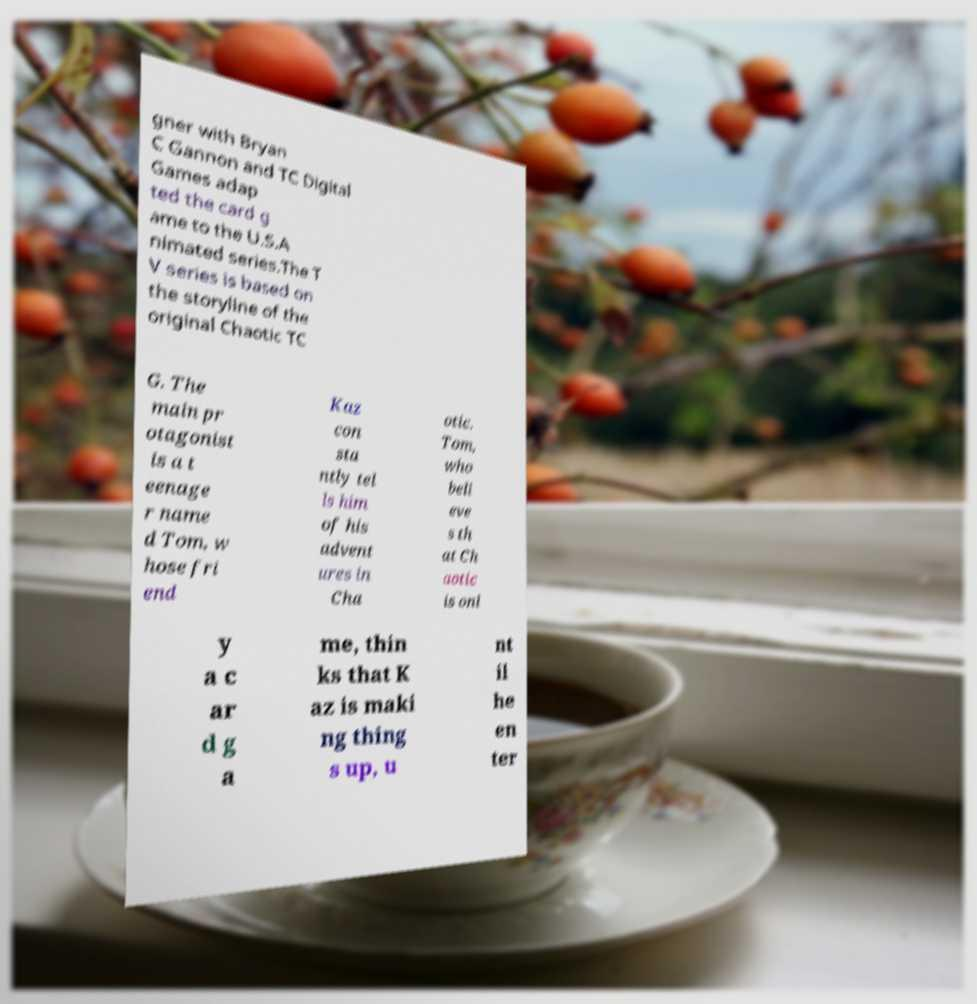Could you assist in decoding the text presented in this image and type it out clearly? gner with Bryan C Gannon and TC Digital Games adap ted the card g ame to the U.S.A nimated series.The T V series is based on the storyline of the original Chaotic TC G. The main pr otagonist is a t eenage r name d Tom, w hose fri end Kaz con sta ntly tel ls him of his advent ures in Cha otic. Tom, who beli eve s th at Ch aotic is onl y a c ar d g a me, thin ks that K az is maki ng thing s up, u nt il he en ter 